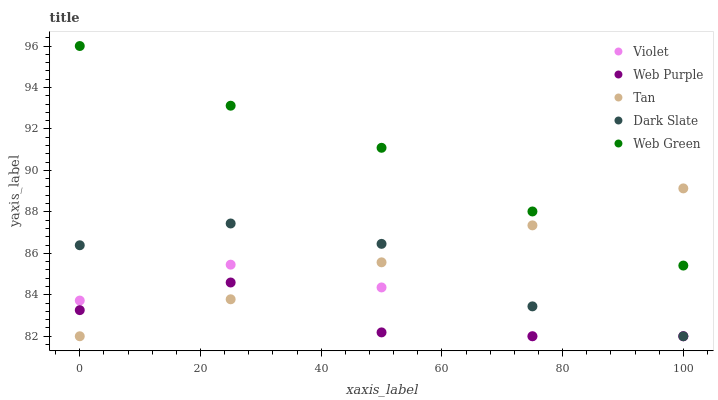Does Web Purple have the minimum area under the curve?
Answer yes or no. Yes. Does Web Green have the maximum area under the curve?
Answer yes or no. Yes. Does Tan have the minimum area under the curve?
Answer yes or no. No. Does Tan have the maximum area under the curve?
Answer yes or no. No. Is Tan the smoothest?
Answer yes or no. Yes. Is Violet the roughest?
Answer yes or no. Yes. Is Web Purple the smoothest?
Answer yes or no. No. Is Web Purple the roughest?
Answer yes or no. No. Does Dark Slate have the lowest value?
Answer yes or no. Yes. Does Web Green have the lowest value?
Answer yes or no. No. Does Web Green have the highest value?
Answer yes or no. Yes. Does Tan have the highest value?
Answer yes or no. No. Is Violet less than Web Green?
Answer yes or no. Yes. Is Web Green greater than Violet?
Answer yes or no. Yes. Does Tan intersect Dark Slate?
Answer yes or no. Yes. Is Tan less than Dark Slate?
Answer yes or no. No. Is Tan greater than Dark Slate?
Answer yes or no. No. Does Violet intersect Web Green?
Answer yes or no. No. 